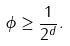<formula> <loc_0><loc_0><loc_500><loc_500>\phi \geq \frac { 1 } { 2 ^ { d } } .</formula> 